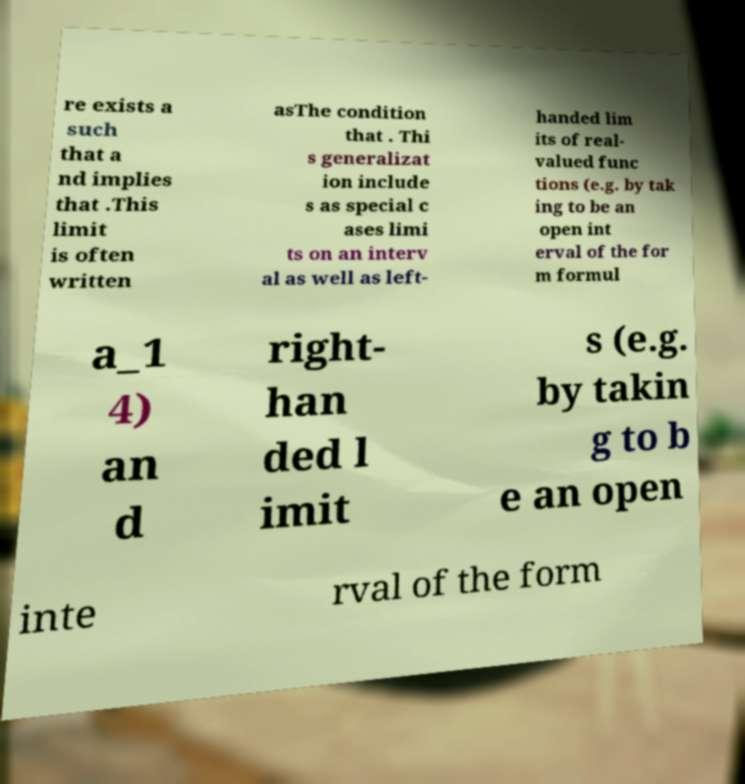Can you read and provide the text displayed in the image?This photo seems to have some interesting text. Can you extract and type it out for me? re exists a such that a nd implies that .This limit is often written asThe condition that . Thi s generalizat ion include s as special c ases limi ts on an interv al as well as left- handed lim its of real- valued func tions (e.g. by tak ing to be an open int erval of the for m formul a_1 4) an d right- han ded l imit s (e.g. by takin g to b e an open inte rval of the form 